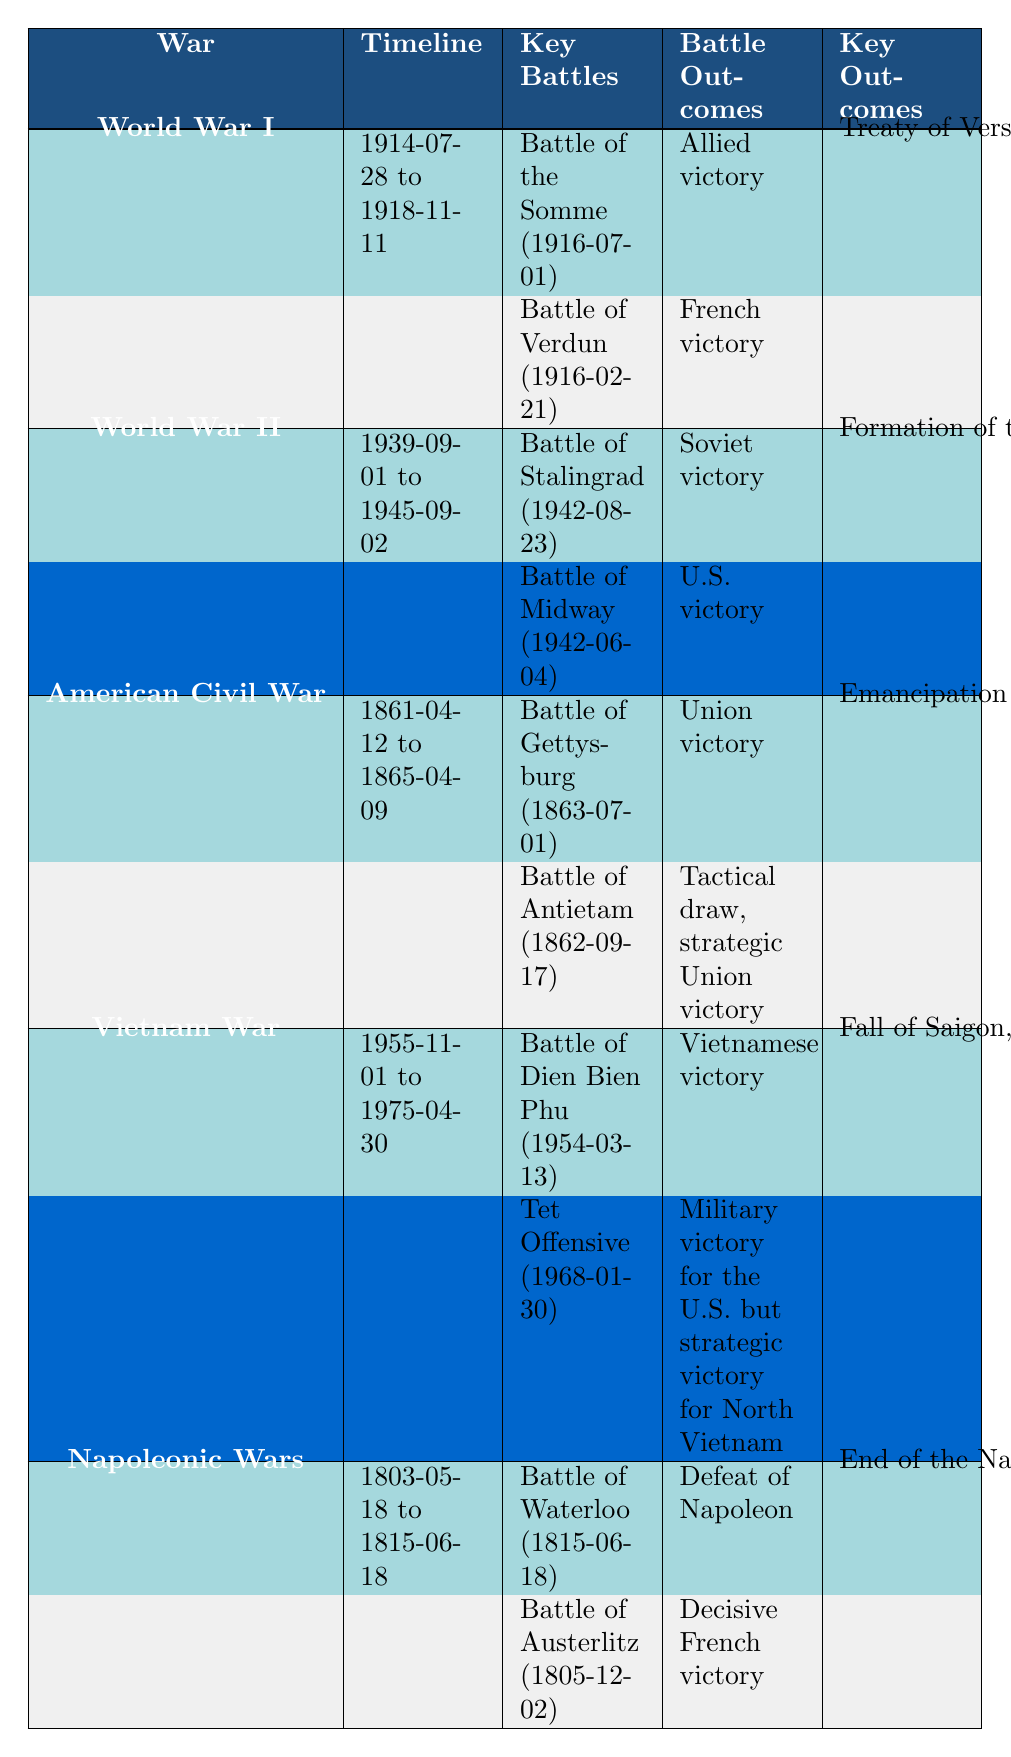What are the key outcomes of World War I? The key outcomes for World War I are listed in the table as "Treaty of Versailles, territorial changes in Europe."
Answer: Treaty of Versailles, territorial changes in Europe Which battle had an outcome of "Defeat of Napoleon"? The table shows that the Battle of Waterloo (on 1815-06-18) had this outcome.
Answer: Battle of Waterloo How many years did the Vietnam War last? The war started on 1955-11-01 and ended on 1975-04-30. Counting the years inclusive, it lasted 20 years.
Answer: 20 years What was the outcome of the Battle of Stalingrad? The table indicates a "Soviet victory" for the Battle of Stalingrad, which took place on 1942-08-23.
Answer: Soviet victory Was there a battle in the American Civil War that ended in a draw? The table notes that the Battle of Antietam resulted in a "Tactical draw, strategic Union victory," indicating that it did indeed end in a draw.
Answer: Yes What are the key battles listed for World War II? By examining the table, the key battles for World War II include the Battle of Stalingrad and the Battle of Midway.
Answer: Battle of Stalingrad, Battle of Midway Which war had the key outcome of "Fall of Saigon"? The Vietnam War is recorded in the table as having the key outcome "Fall of Saigon."
Answer: Vietnam War Which war lasted from 1939 to 1945? The table shows that World War II had a timeline from 1939-09-01 to 1945-09-02.
Answer: World War II Name a key battle from the Napoleonic Wars. The table lists the Battle of Austerlitz as a key battle from the Napoleonic Wars.
Answer: Battle of Austerlitz Which war had both a tactical draw and a strategic Union victory? According to the table, the American Civil War included the Battle of Antietam, which ended in a tactical draw but was strategically a Union victory.
Answer: American Civil War 